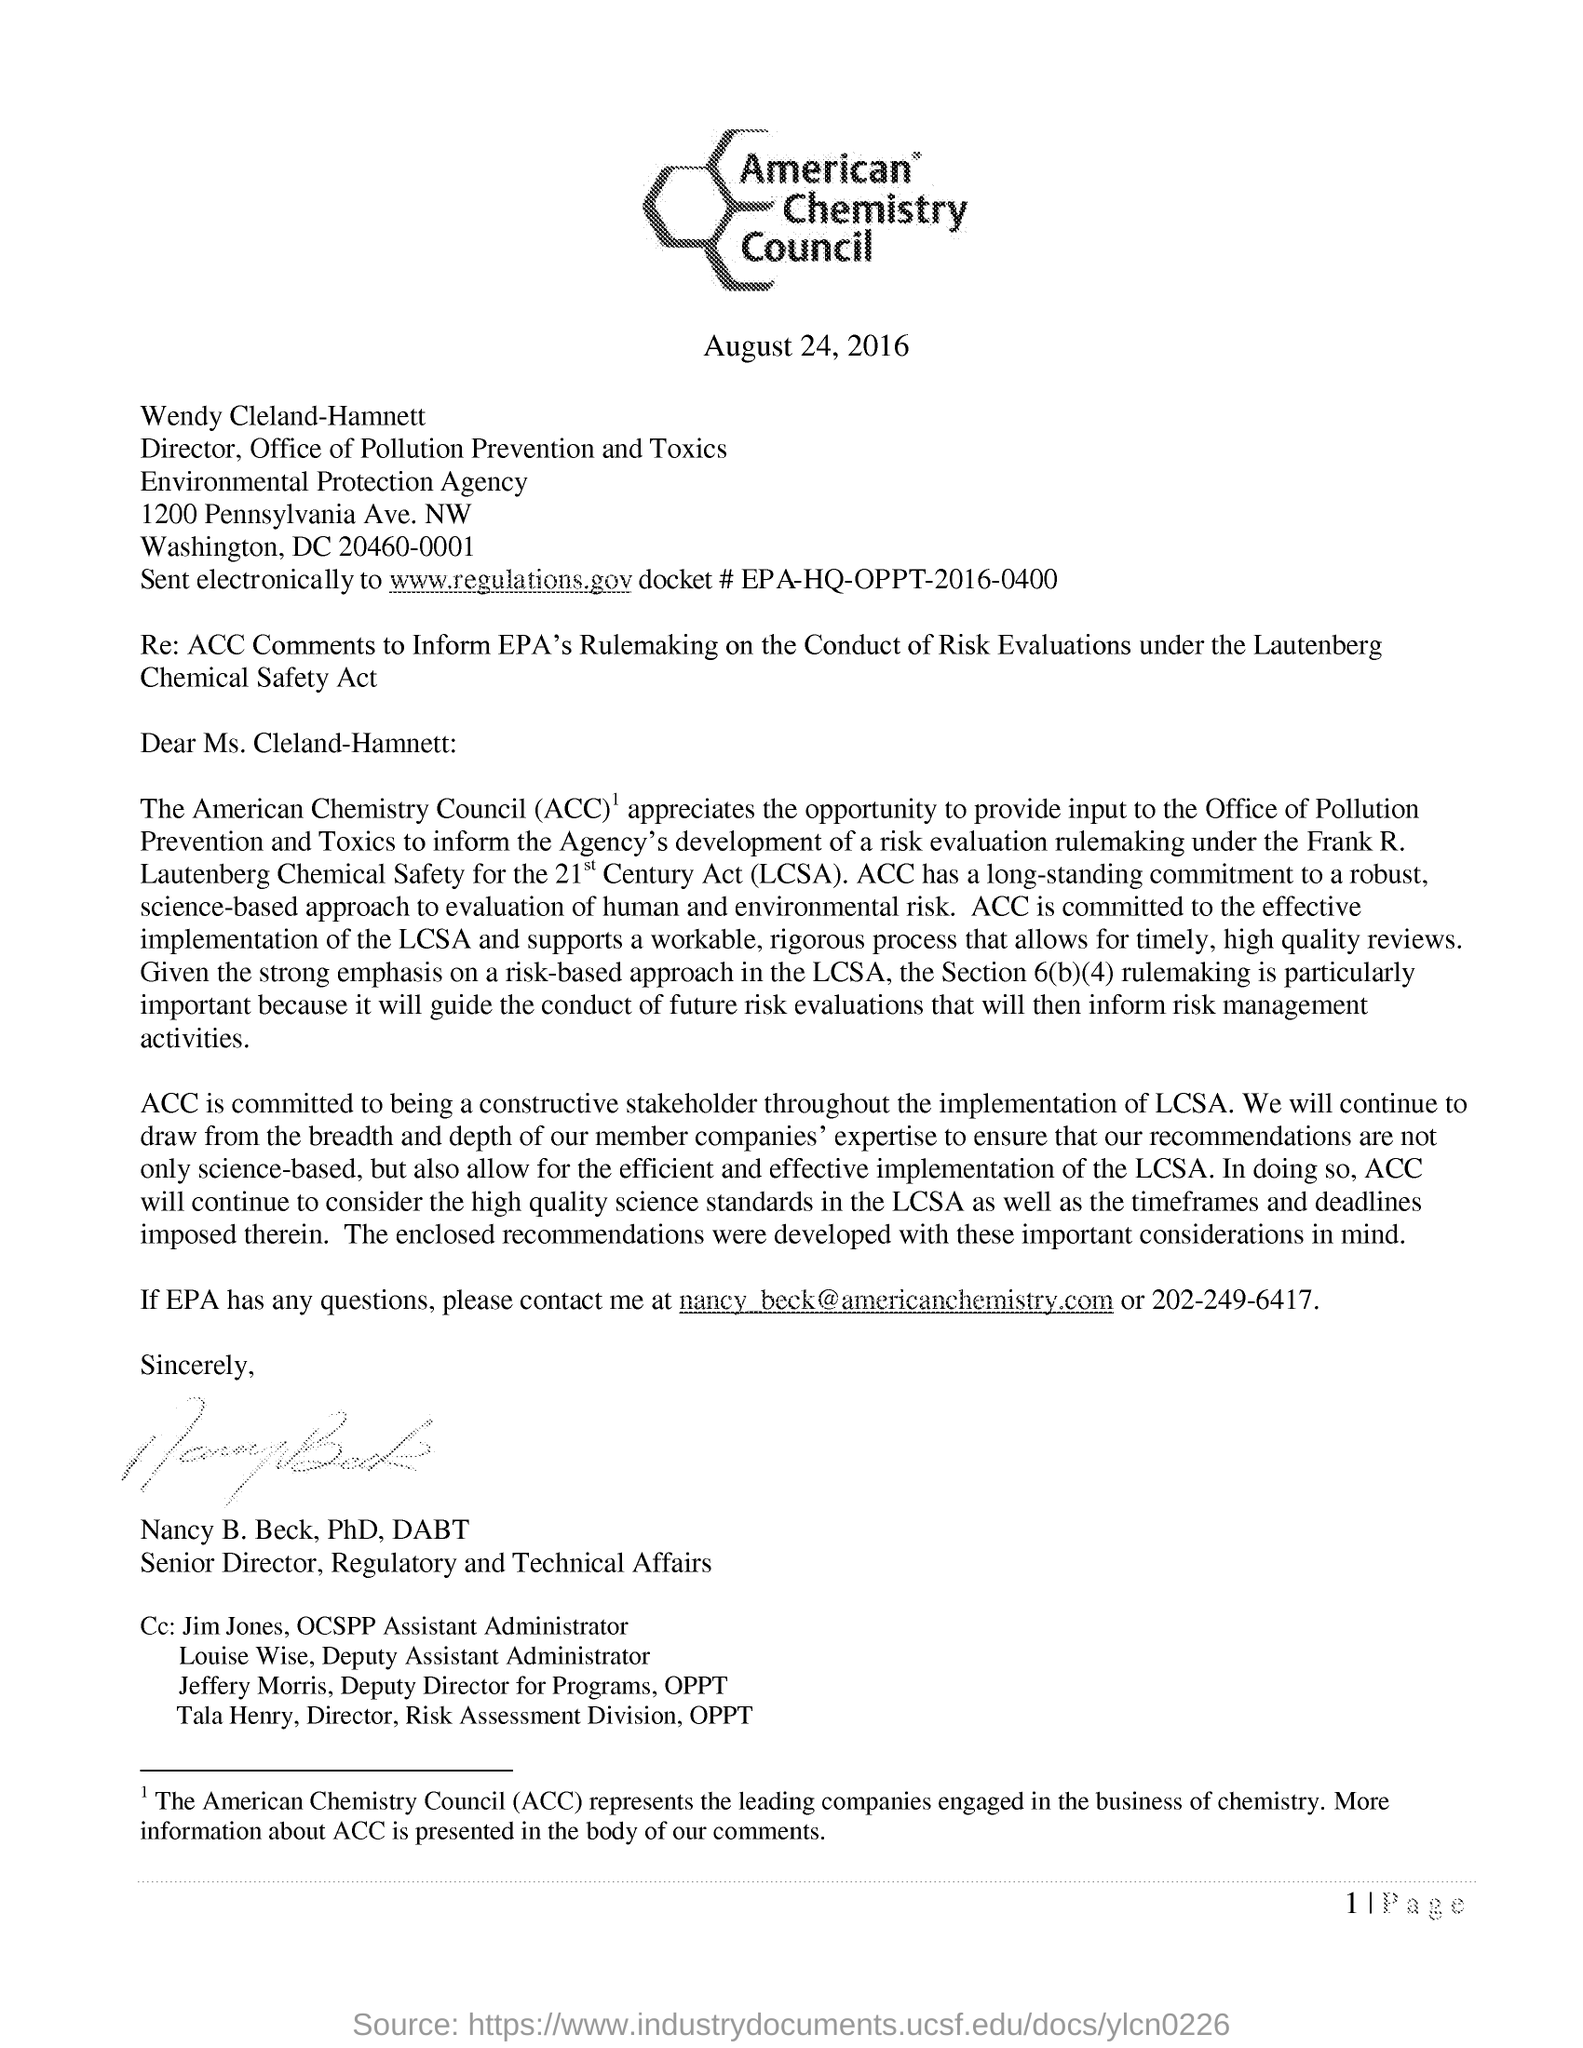Mention a couple of crucial points in this snapshot. ACC represents leading companies engaged in the business of chemistry, committed to providing innovative solutions and advancing sustainable practices for the benefit of society. The full form of ACC is the American Chemistry Council, which is a trade association representing the business of chemistry and its members. The letter is from Nancy B. Beck. The date mentioned in this letter is August 24, 2016. The director of the Office of Pollution Prevention and Toxics is Wendy Cleland-Hamnett. 